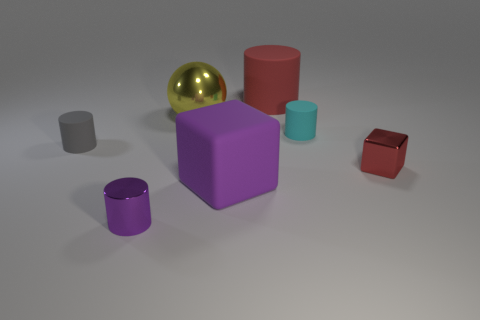What size is the red object that is the same material as the yellow ball?
Make the answer very short. Small. The metal thing behind the tiny object that is on the left side of the tiny purple metallic cylinder is what color?
Your response must be concise. Yellow. What number of large yellow objects are made of the same material as the large red cylinder?
Give a very brief answer. 0. How many shiny objects are big gray blocks or purple blocks?
Give a very brief answer. 0. What material is the block that is the same size as the red cylinder?
Offer a very short reply. Rubber. Is there a green cylinder that has the same material as the large yellow ball?
Your answer should be very brief. No. What is the shape of the tiny thing to the left of the tiny cylinder that is in front of the big matte object that is in front of the small gray object?
Provide a short and direct response. Cylinder. There is a shiny cylinder; is its size the same as the block that is to the left of the small red metallic cube?
Offer a very short reply. No. What shape is the rubber thing that is in front of the large metal sphere and to the right of the large purple object?
Your response must be concise. Cylinder. How many small objects are either blocks or cyan rubber things?
Offer a terse response. 2. 